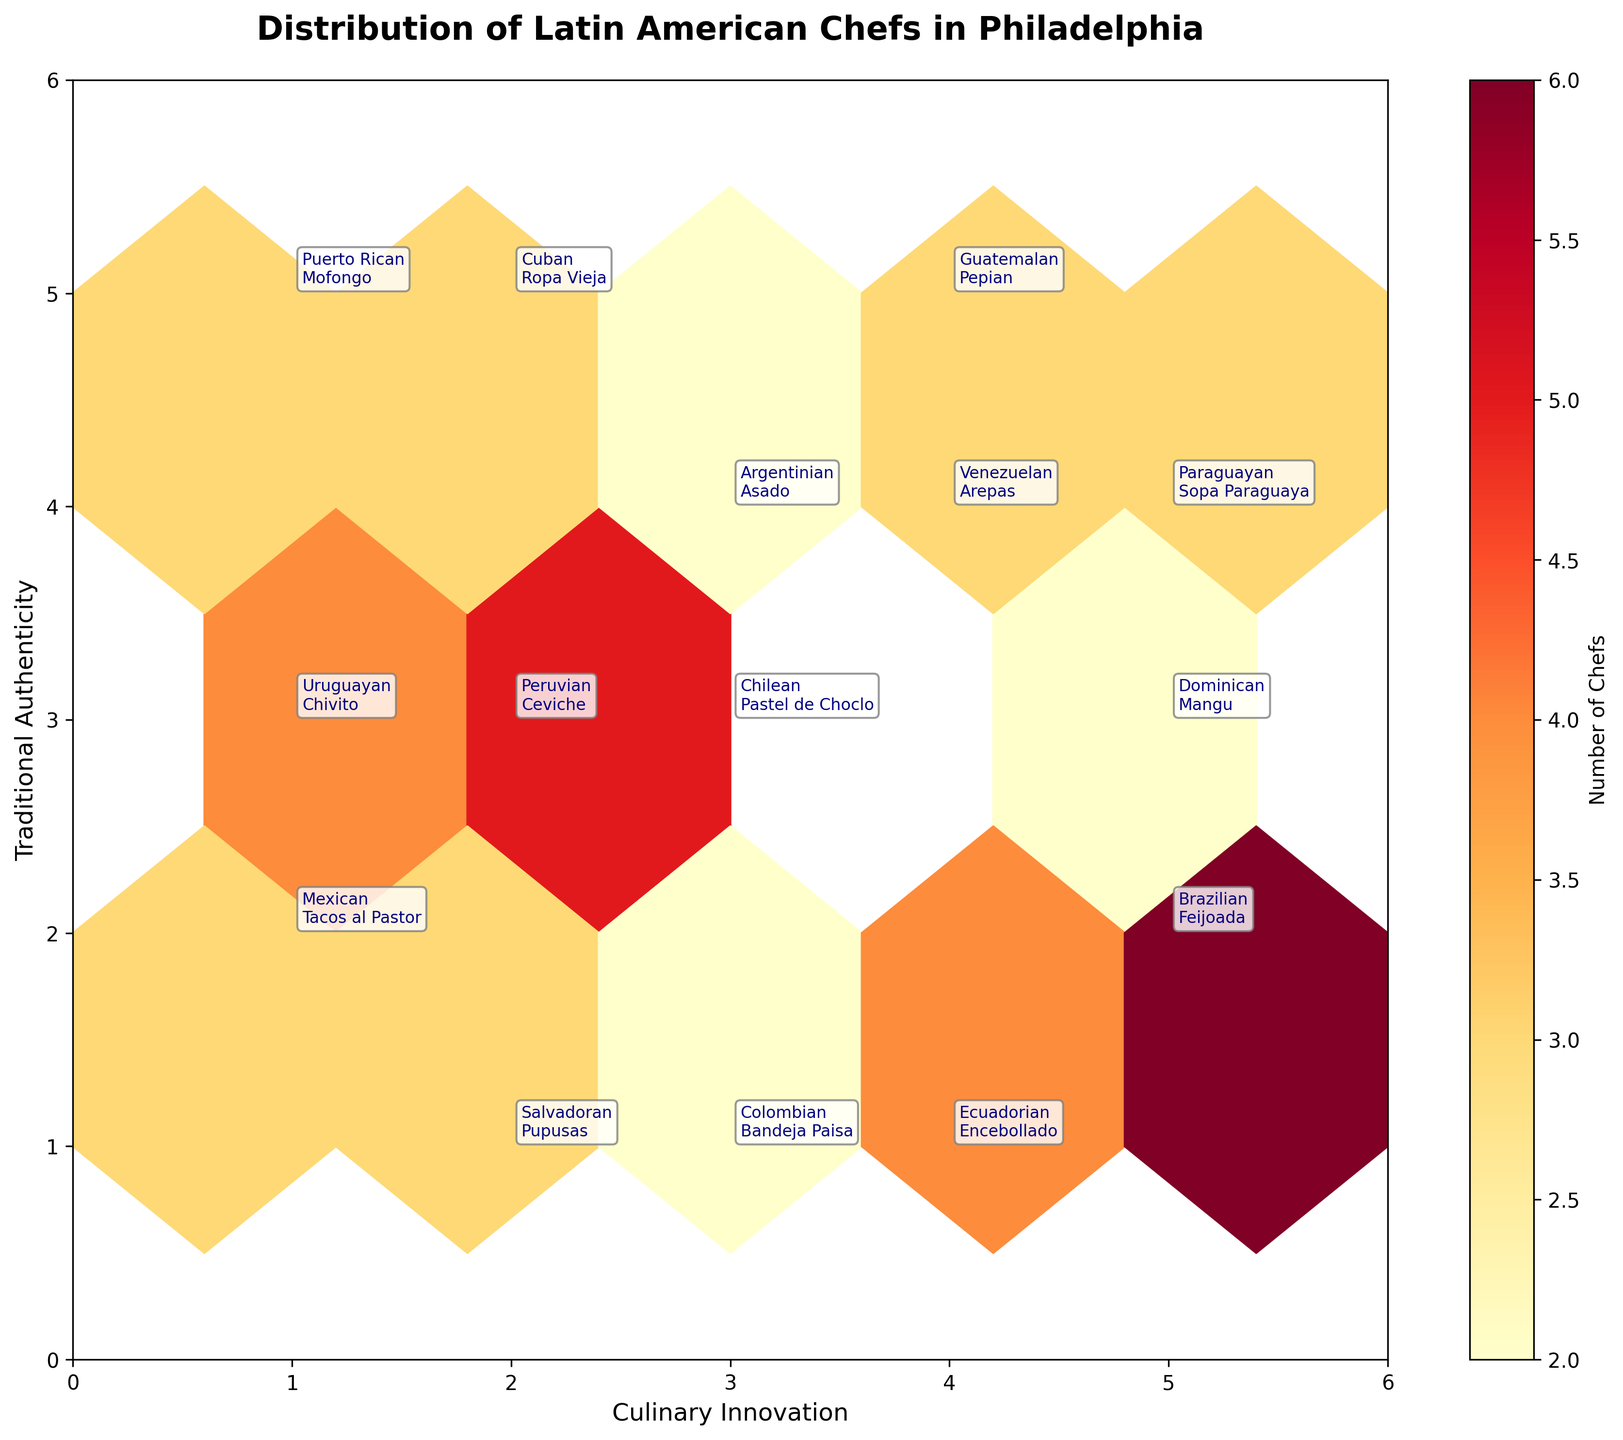What is the title of the hexbin plot? The title of the plot is usually displayed at the top of the figure in a larger font size. By looking at the top of the plot, we see the title clearly written.
Answer: Distribution of Latin American Chefs in Philadelphia What does the color scale represent in the hexbin plot? The color scale is usually indicated by the colorbar on the side of the plot. In this case, the colorbar label shows that the colors represent the "Number of Chefs."
Answer: Number of Chefs How many distinct chef nationalities are annotated on the plot? By counting the unique annotations of chef nationalities visible in the hexbin plot, we cover all unique names mentioned. We can tally that there are 14 distinct chef nationalities.
Answer: 14 Which chef nationality and specialty has the highest number of chefs in the plot? To determine this, we look at the hexbin color that represents the highest count value. We then find the corresponding nationality and specialty annotated at that position. The brightest color is at coordinates (5, 2), which corresponds to "Brazilian, Feijoada."
Answer: Brazilian, Feijoada Where are Cuban chefs and their specialty located on the hexbin plot? By scanning the annotations for the mentioned chef nationality and specialty, we find that "Cuban, Ropa Vieja" is annotated. This specific nationality is found at the hexbin plot coordinates (2, 5).
Answer: (2, 5) Which nationality has the specialty "Pupusas"? To find this, we locate the annotation for "Pupusas" and note the nationality associated with it. Pupusas are tagged with "Salvadoran."
Answer: Salvadoran Compare the number of Mexican and Peruvian chefs mentioned in the plot. Which nationality has more chefs? From the hexbin plot, we note the count at positions (1, 2) for Mexican (3 chefs) and (2, 3) for Peruvian (5 chefs). By comparing, we see that Peruvian nationality has more chefs.
Answer: Peruvian How many chef nationalities are placed at the highest 'Traditional Authenticity' value on the hexbin plot? By looking at the "Traditional Authenticity" axis and finding its maximum value (5), we count the annotations at this level. Observing, we see that there are three nationalities: Cuban, Puerto Rican, and Guatemalan.
Answer: 3 Which two nationalities are closest to each other in terms of both 'Culinary Innovation' and 'Traditional Authenticity'? By visually identifying the proximity of annotations, we see that Peruvian and Chilean chefs are located adjacent to each other at (2, 3) and (3, 3), respectively, making them the closest.
Answer: Peruvian and Chilean In terms of grid size, how many chefs specialize in 'Ceviche' compared to 'Tacos al Pastor'? First, note the count values at the respective specialties: 'Ceviche' (2, 3) has 5 chefs, and 'Tacos al Pastor' (1, 2) has 3 chefs. Therefore, the comparison shows more chefs specialize in 'Ceviche' than in 'Tacos al Pastor.'
Answer: Ceviche: 5, Tacos al Pastor: 3 